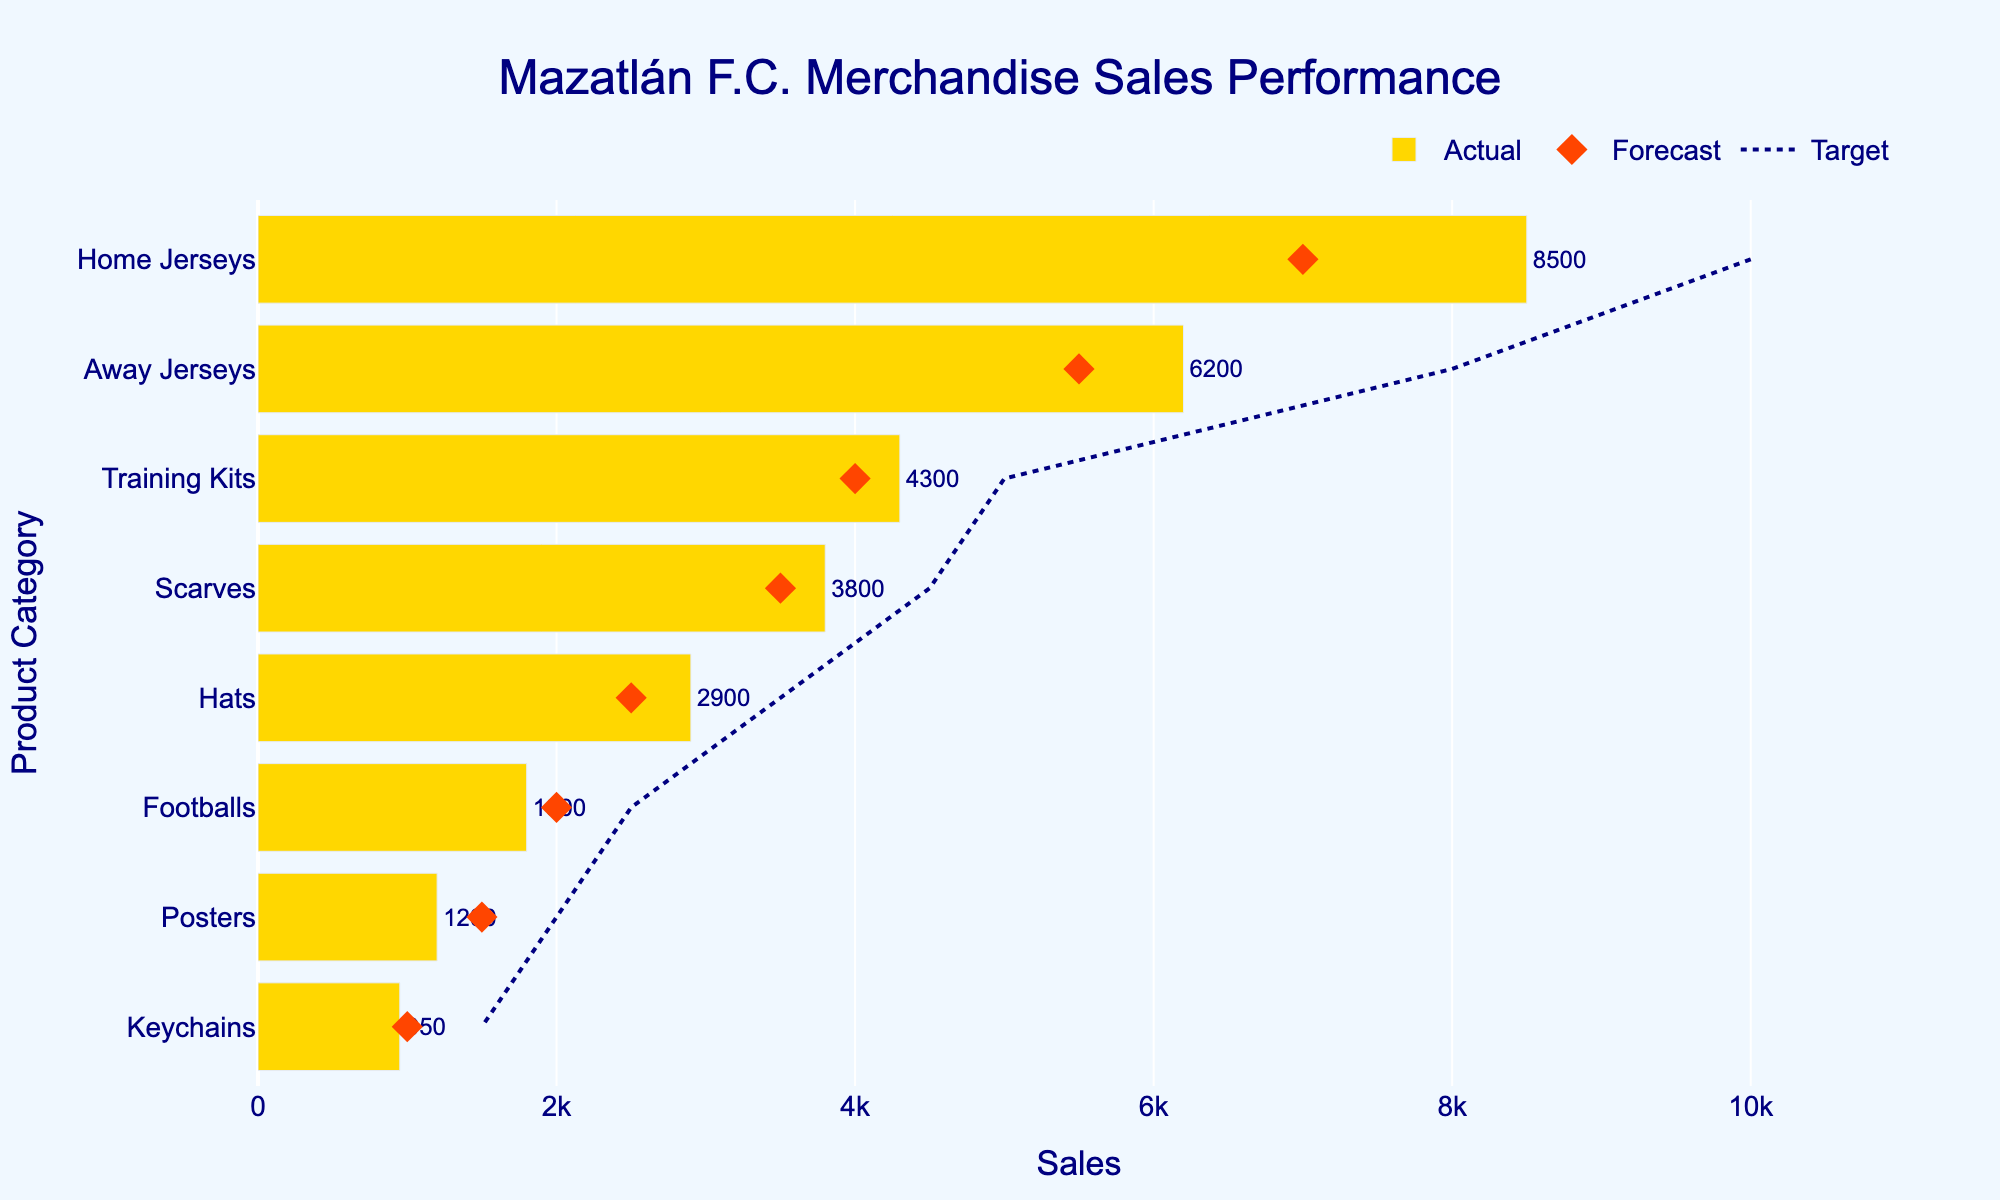How many product categories are listed in the figure? There are 8 different categories listed in the figure, as shown on the y-axis.
Answer: 8 What is the title of the figure? The title is displayed at the top of the figure and reads "Mazatlán F.C. Merchandise Sales Performance".
Answer: Mazatlán F.C. Merchandise Sales Performance How many products exceeded their forecasted sales? By comparing the Actual sales bars and the Forecast markers for each category, we see that Home Jerseys, Away Jerseys, Training Kits, and Scarves exceeded their forecasted sales. This makes a total of 4 products.
Answer: 4 Which product category has the highest actual sales? By looking at the length of the bars representing actual sales, the Home Jerseys category has the highest value which is 8500.
Answer: Home Jerseys What is the difference between the actual sales and target sales for Training Kits? The actual sales for Training Kits is 4300, and the target sales is 5000. The difference is 5000 - 4300.
Answer: 700 What is the aggregate actual sales of Hats and Footballs? The actual sales for Hats is 2900 and for Footballs is 1800. Adding them together gives us 2900 + 1800.
Answer: 4700 Which category came closest to meeting its target sales? By comparing the actual sales bars to the target sales lines, Training Kits are closest to their target with 4300 actual sales against a target of 5000.
Answer: Training Kits How does the actual sales of Keychains compare to its forecasted sales? The actual sales of Keychains is 950, while the forecasted sales is 1000. The actual sales is slightly below the forecast by 50 units.
Answer: Below forecast by 50 units Which product has the smallest actual sales figure? The shortest bar on the figure represents the Posters category, which has actual sales of 1200.
Answer: Posters Between Away Jerseys and Scarves, which product exceeded its forecast by a larger margin? The Away Jerseys had actual sales of 6200 and forecasted sales of 5500, a difference of 700. Scarves had actual sales of 3800 and forecasted sales of 3500, a difference of 300.
Answer: Away Jerseys by 700 units 